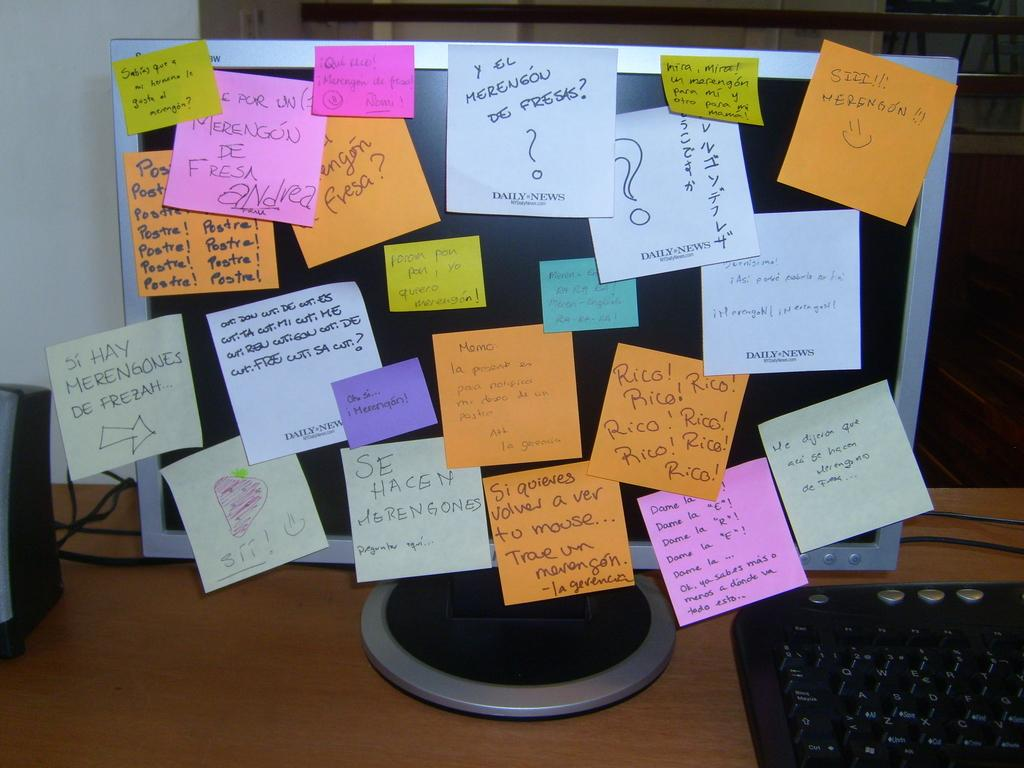<image>
Offer a succinct explanation of the picture presented. post it notes all over a computer screen with one of them that says 'si hay merengones de frezah' 